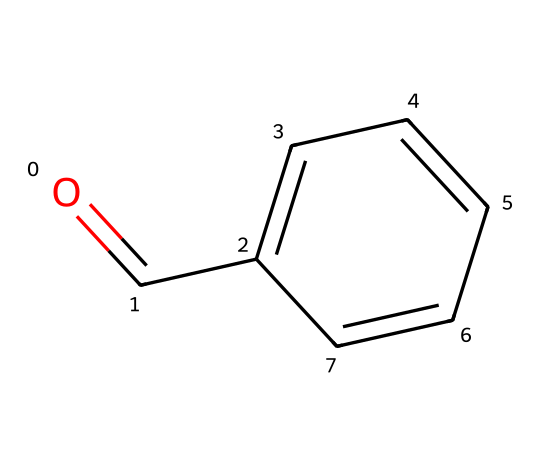What is the functional group present in benzaldehyde? The benzaldehyde structure contains a carbonyl (C=O) group attached to a benzene ring. The presence of this carbonyl group indicates that it is an aldehyde.
Answer: carbonyl How many carbon atoms are in benzaldehyde? By examining the SMILES representation, we see the carbon atoms in both the carbonyl group and the benzene ring. The carbonyl contributes 1 carbon, and the aromatic ring consists of 6 carbons. Thus, there are a total of 7 carbon atoms.
Answer: 7 What type of aromatic compound is benzaldehyde? Benzaldehyde is derived from benzene and contains a carbonyl functional group, classifying it as a substituted aromatic compound with aldehyde characteristics.
Answer: substituted aromatic What is the total number of hydrogen atoms in benzaldehyde? In the SMILES structure, the benzene ring normally has 6 hydrogen atoms, but the carbonyl group replaces one hydrogen, resulting in 5 hydrogen atoms in total.
Answer: 6 What is the significance of the carbonyl group in aldehydes? The carbonyl group is pivotal because it imparts reactivity to aldehydes, contributing to their characteristic properties, including their ability to undergo oxidation and participate in nucleophilic addition reactions.
Answer: reactivity Which type of reactions can benzaldehyde undergo due to its functional group? The presence of the carbonyl group allows benzaldehyde to undergo nucleophilic addition reactions, such as those involving alcohols to form hemiacetals or acetals. This is a notable behavior of carbonyls in organic chemistry.
Answer: nucleophilic addition 